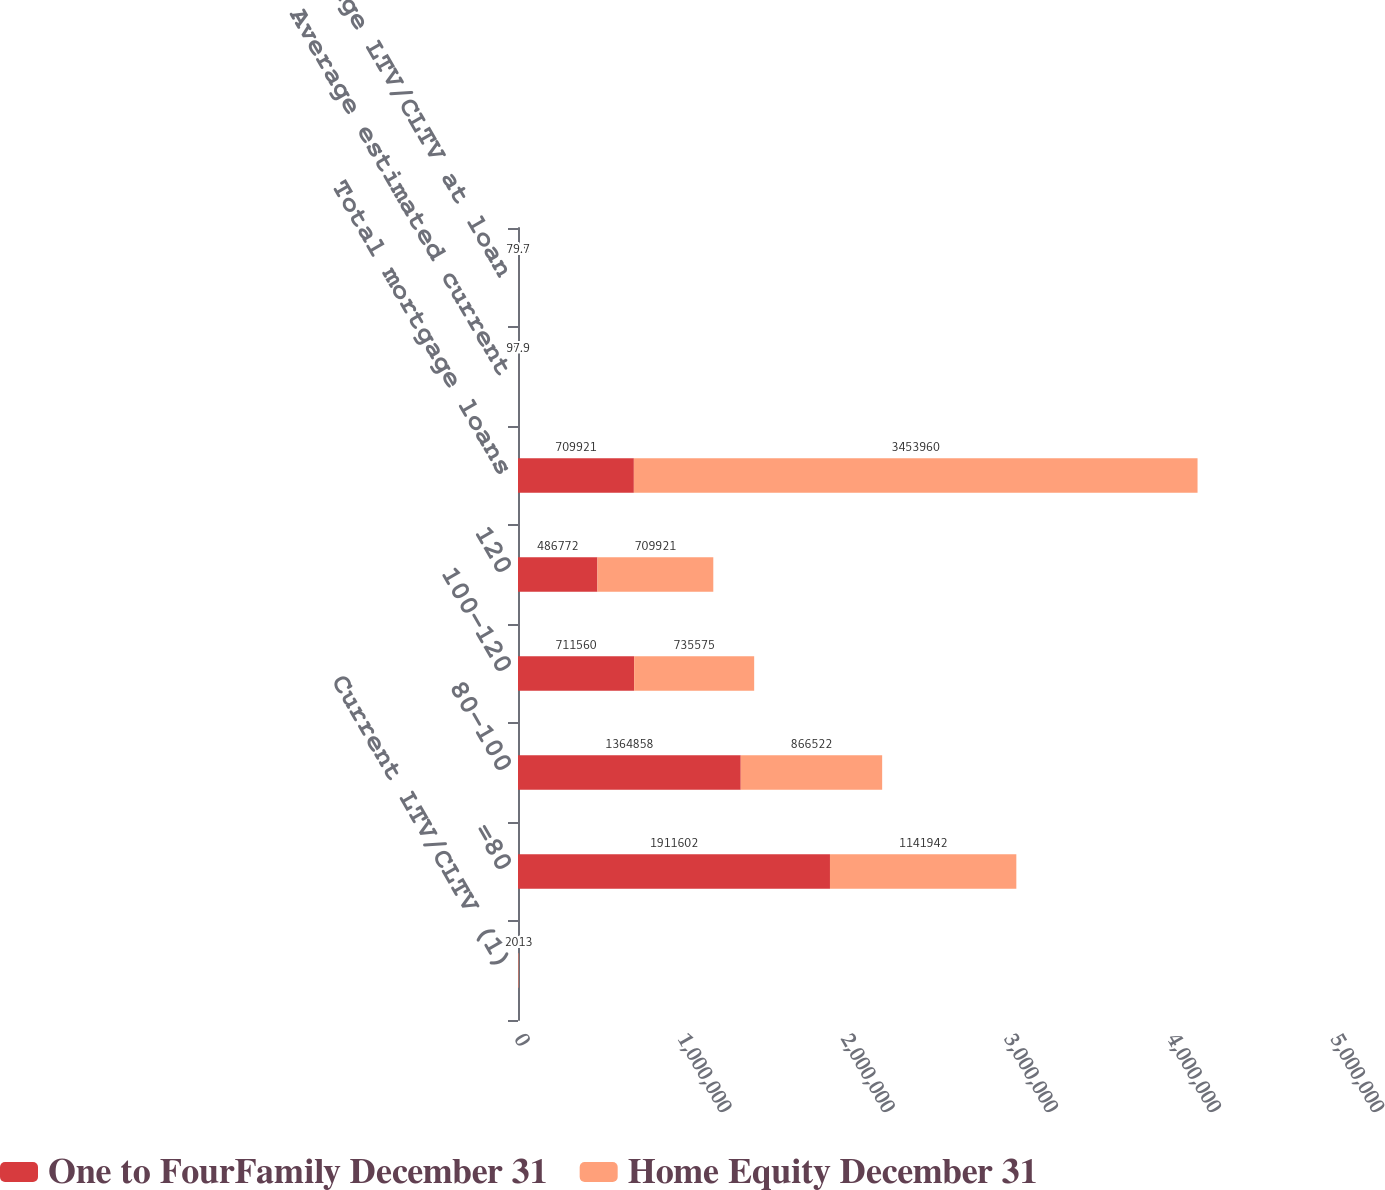<chart> <loc_0><loc_0><loc_500><loc_500><stacked_bar_chart><ecel><fcel>Current LTV/CLTV (1)<fcel>=80<fcel>80-100<fcel>100-120<fcel>120<fcel>Total mortgage loans<fcel>Average estimated current<fcel>Average LTV/CLTV at loan<nl><fcel>One to FourFamily December 31<fcel>2013<fcel>1.9116e+06<fcel>1.36486e+06<fcel>711560<fcel>486772<fcel>709921<fcel>89.9<fcel>71.5<nl><fcel>Home Equity December 31<fcel>2013<fcel>1.14194e+06<fcel>866522<fcel>735575<fcel>709921<fcel>3.45396e+06<fcel>97.9<fcel>79.7<nl></chart> 